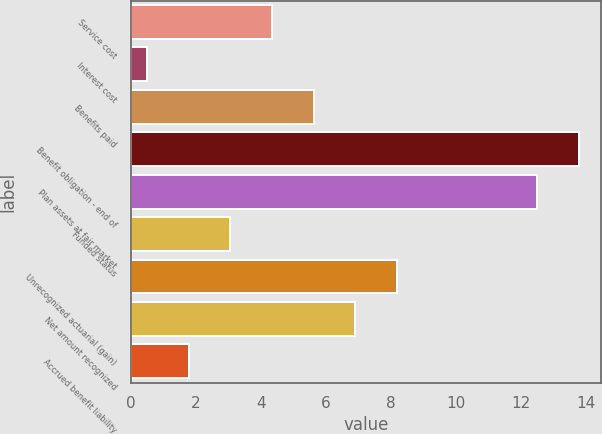Convert chart. <chart><loc_0><loc_0><loc_500><loc_500><bar_chart><fcel>Service cost<fcel>Interest cost<fcel>Benefits paid<fcel>Benefit obligation - end of<fcel>Plan assets at fair market<fcel>Funded status<fcel>Unrecognized actuarial (gain)<fcel>Net amount recognized<fcel>Accrued benefit liability<nl><fcel>4.34<fcel>0.5<fcel>5.62<fcel>13.78<fcel>12.5<fcel>3.06<fcel>8.18<fcel>6.9<fcel>1.78<nl></chart> 